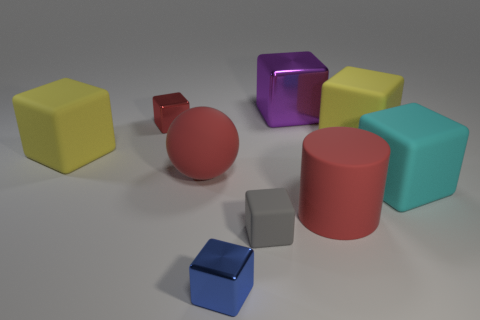What material is the small cube that is the same color as the cylinder?
Your answer should be compact. Metal. The matte object that is both to the right of the blue shiny thing and behind the cyan thing has what shape?
Provide a short and direct response. Cube. What number of tiny red things are the same material as the blue thing?
Your response must be concise. 1. Is the number of large yellow cubes in front of the big purple shiny object less than the number of yellow blocks?
Provide a succinct answer. No. There is a big yellow matte block on the left side of the large purple cube; are there any small cubes that are in front of it?
Your answer should be very brief. Yes. Are there any other things that have the same shape as the large purple metal object?
Give a very brief answer. Yes. Does the gray block have the same size as the red sphere?
Offer a very short reply. No. What material is the yellow object on the right side of the block behind the small red shiny block that is in front of the purple shiny cube?
Your response must be concise. Rubber. Are there the same number of big purple metal objects that are in front of the blue metallic cube and big yellow objects?
Give a very brief answer. No. Is there any other thing that has the same size as the purple metal block?
Ensure brevity in your answer.  Yes. 